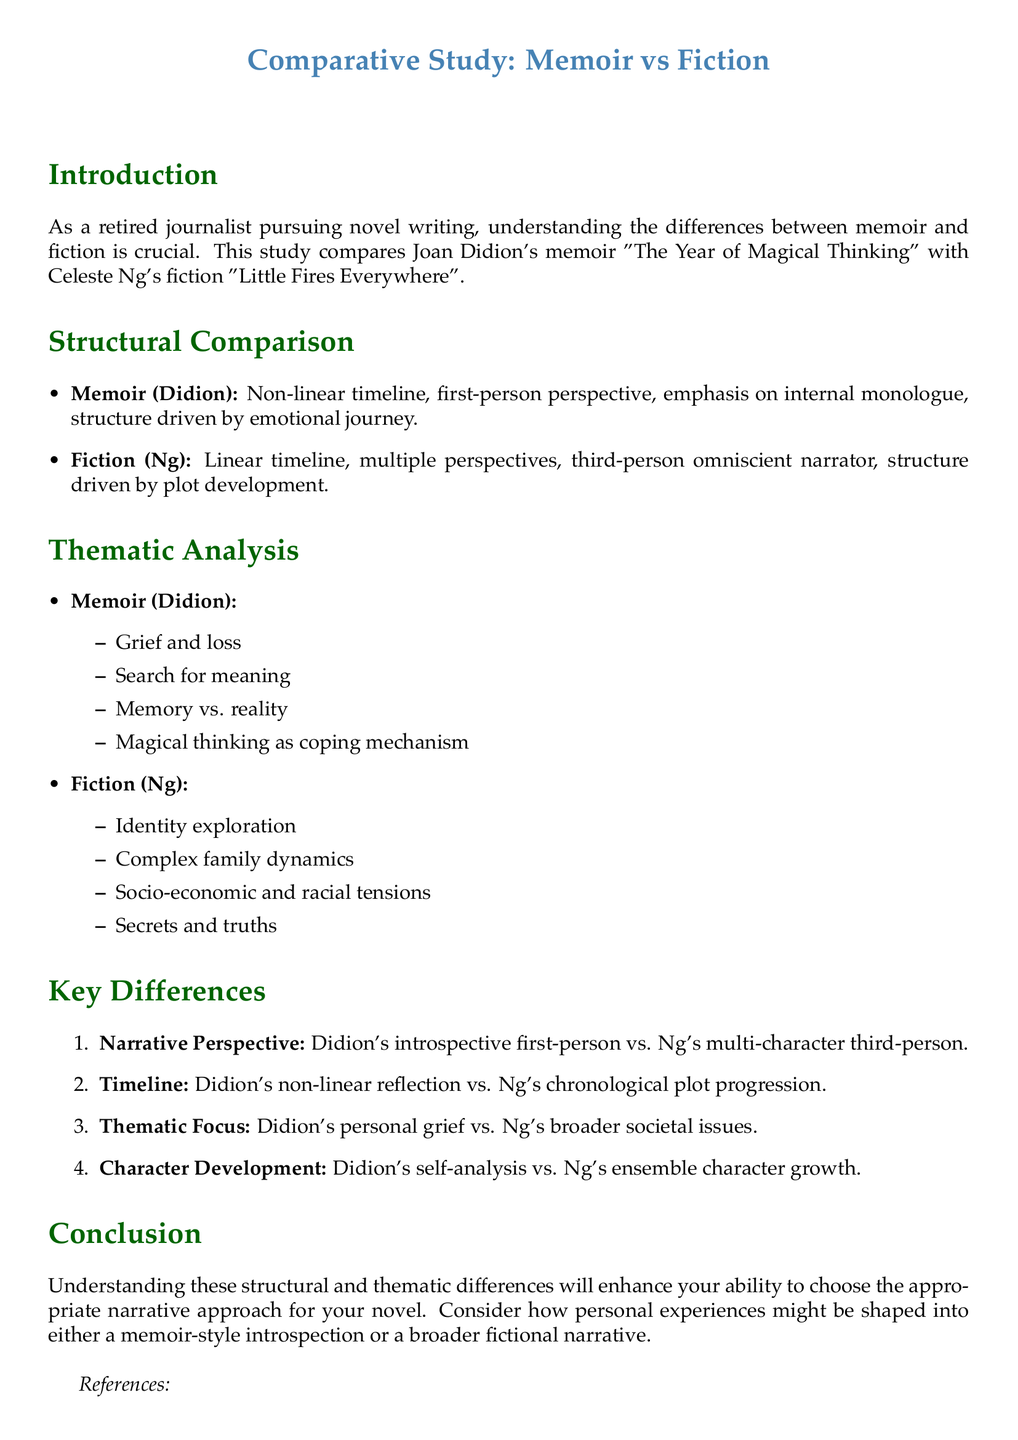What are the titles of the works compared in this study? The document compares Joan Didion's memoir "The Year of Magical Thinking" with Celeste Ng's fiction "Little Fires Everywhere".
Answer: "The Year of Magical Thinking" and "Little Fires Everywhere" What perspective does Didion use in her memoir? The document states that Didion uses a first-person perspective in her memoir.
Answer: First-person What is the primary theme of Didion's memoir? The document lists "Grief and loss" as a primary theme in Didion's memoir.
Answer: Grief and loss What type of narrator does Ng use in her fiction? The document indicates that Ng employs a third-person omniscient narrator in her fiction.
Answer: Third-person omniscient Which narrative structure does Didion's work utilize? The document describes Didion's memoir as having a non-linear timeline.
Answer: Non-linear timeline What key difference involves character development between the two works? The document highlights Didion's self-analysis versus Ng's ensemble character growth as a key difference.
Answer: Self-analysis vs. ensemble character growth What thematic focus is emphasized in Ng's fiction? The document lists "Socio-economic and racial tensions" as a thematic focus in Ng's fiction.
Answer: Socio-economic and racial tensions What year was Didion's memoir published? The document includes the publication date for Didion's memoir as 2005.
Answer: 2005 What is the structural difference regarding timelines? The document states that Didion's work has a non-linear reflection, while Ng's has chronological plot progression.
Answer: Non-linear vs. chronological What aspect of writing does the conclusion encourage? The document suggests considering how personal experiences might be shaped into either a memoir-style introspection or a broader fictional narrative.
Answer: Narrative approach 